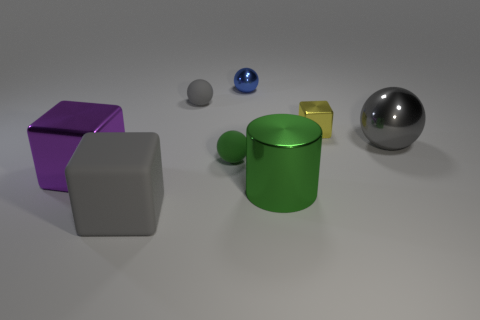How many things are either large red balls or shiny cubes that are behind the big gray sphere?
Offer a terse response. 1. Are there fewer gray matte objects than big green metallic cylinders?
Ensure brevity in your answer.  No. The small object that is behind the small rubber sphere behind the tiny yellow metal block is what color?
Offer a terse response. Blue. There is a small object that is the same shape as the big matte object; what is it made of?
Your response must be concise. Metal. How many metallic things are either blue balls or cubes?
Give a very brief answer. 3. Is the material of the gray object that is to the right of the blue thing the same as the block right of the gray matte cube?
Offer a terse response. Yes. Are there any small blue objects?
Provide a short and direct response. Yes. Does the large gray thing that is in front of the big green metal object have the same shape as the gray rubber thing that is behind the large gray rubber cube?
Your answer should be very brief. No. Is there a yellow thing made of the same material as the cylinder?
Provide a succinct answer. Yes. Do the sphere to the right of the tiny blue metal object and the tiny yellow cube have the same material?
Provide a short and direct response. Yes. 